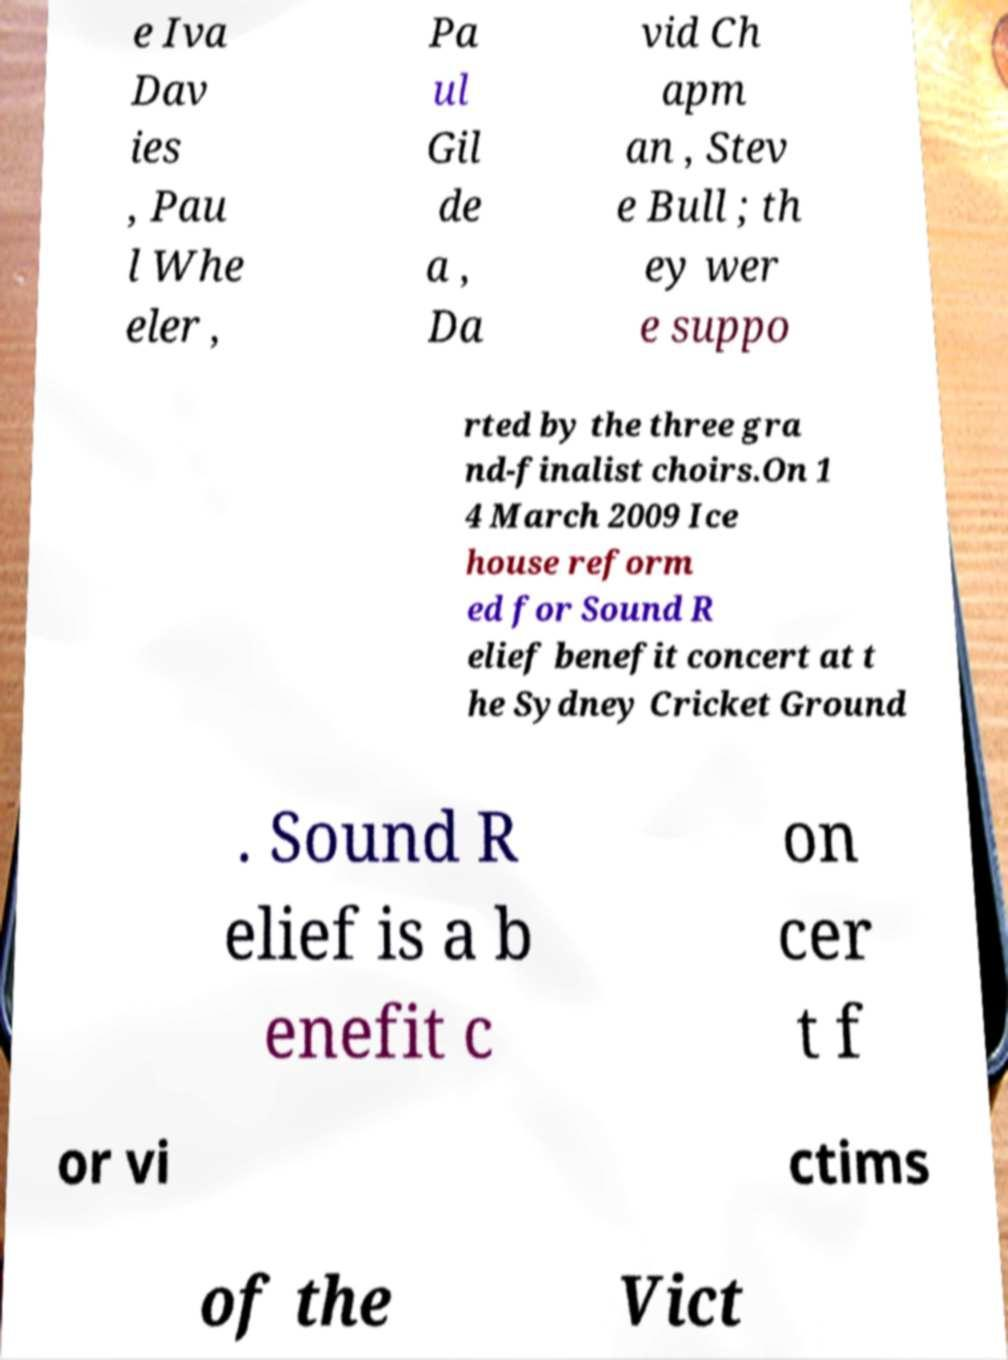Could you extract and type out the text from this image? e Iva Dav ies , Pau l Whe eler , Pa ul Gil de a , Da vid Ch apm an , Stev e Bull ; th ey wer e suppo rted by the three gra nd-finalist choirs.On 1 4 March 2009 Ice house reform ed for Sound R elief benefit concert at t he Sydney Cricket Ground . Sound R elief is a b enefit c on cer t f or vi ctims of the Vict 